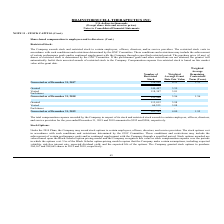According to Brainstorm Cell Therapeutics's financial document, What is the total compensation expense recorded by the Company for the year ended December 31, 2018? According to the financial document, $506. The relevant text states: "ed December 31, 2019 and 2018 amounted to $392 and $506, respectively. Stock Options: Under the 2014 Plans, the Company may award stock options to certain..." Also, What is the total compensation expense recorded by the Company for the year ended December 31, 2019? According to the financial document, $392. The relevant text states: "year ended December 31, 2019 and 2018 amounted to $392 and $506, respectively. Stock Options: Under the 2014 Plans, the Company may award stock options to..." Also, Who does the Company award and restrict stock to? certain employees, officers, directors, and/or service providers. The document states: "The Company awards stock and restricted stock to certain employees, officers, directors, and/or service providers. The restricted stock vests in accor..." Also, can you calculate: What is the percentage of granted restricted stock in total noninvested stock as of December 31, 2018? Based on the calculation: 144,447/152,908, the result is 94.47 (percentage). This is based on the information: "Granted 144,447 3.59 Nonvested as of December 31, 2018 152,908 3.96 1.56..." The key data points involved are: 144,447, 152,908. Also, can you calculate: What is the percentage change in the number of noninvested restricted stock from 2018 to 2019? To answer this question, I need to perform calculations using the financial data. The calculation is: (201,385-152,908)/152,908, which equals 31.7 (percentage). This is based on the information: "Nonvested as of December 31, 2018 152,908 3.96 1.56 Nonvested as of December 31, 2019 201,385 4.00 1.95..." The key data points involved are: 152,908, 201,385. Also, can you calculate: What is the change in the granted restricted stocks from 2018 to 2019? Based on the calculation: 113,012-144,447, the result is -31435. This is based on the information: "Granted 144,447 3.59 Granted 113,012 3.98..." The key data points involved are: 113,012, 144,447. 